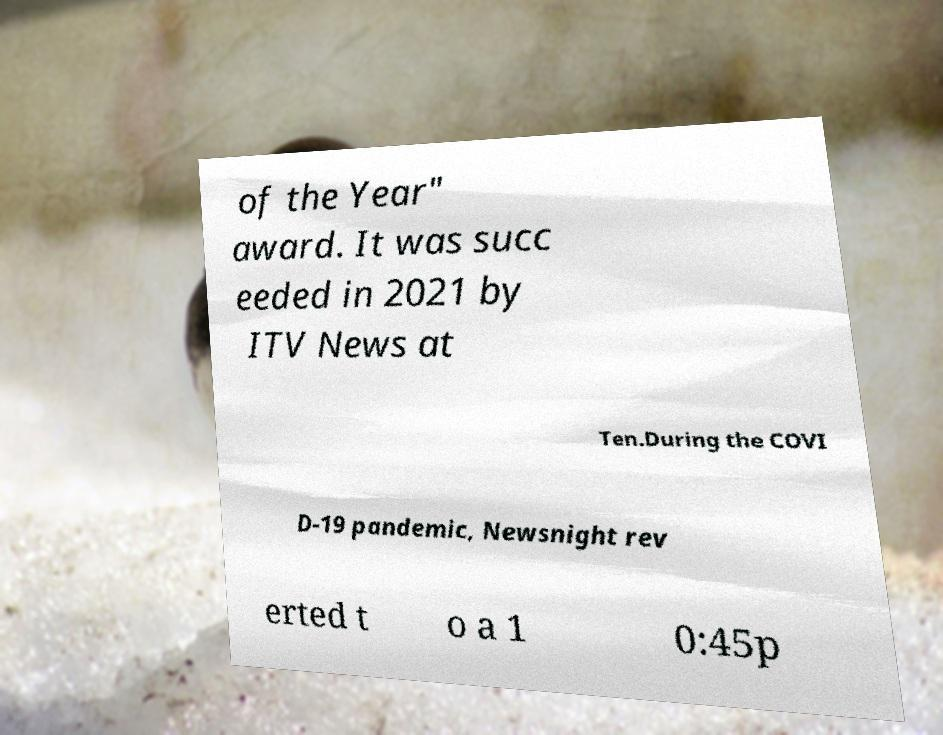Can you accurately transcribe the text from the provided image for me? of the Year" award. It was succ eeded in 2021 by ITV News at Ten.During the COVI D-19 pandemic, Newsnight rev erted t o a 1 0:45p 